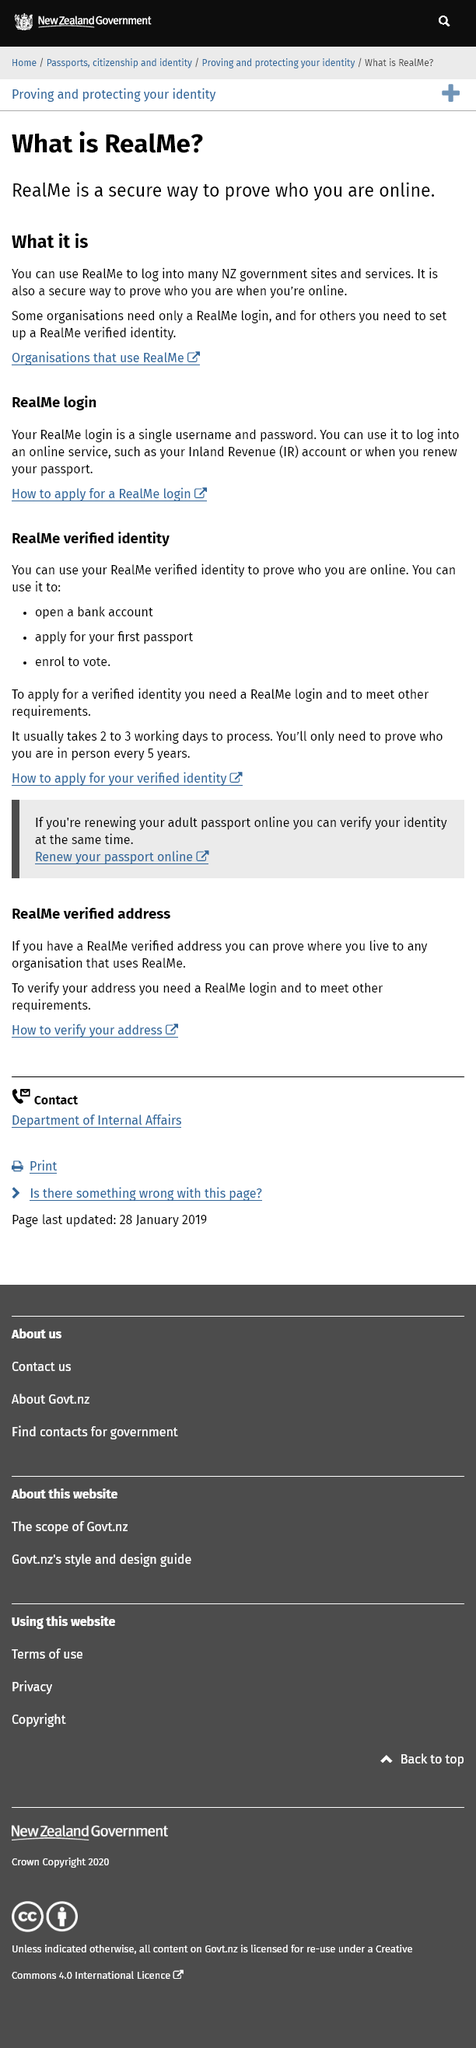Draw attention to some important aspects in this diagram. Realme operates in New Zealand, a country located in the Pacific region. Realme requires a single username and password to access its login system. Realme serves the function of secure online identification by allowing individuals to authenticate their identity in a safe and efficient manner. 